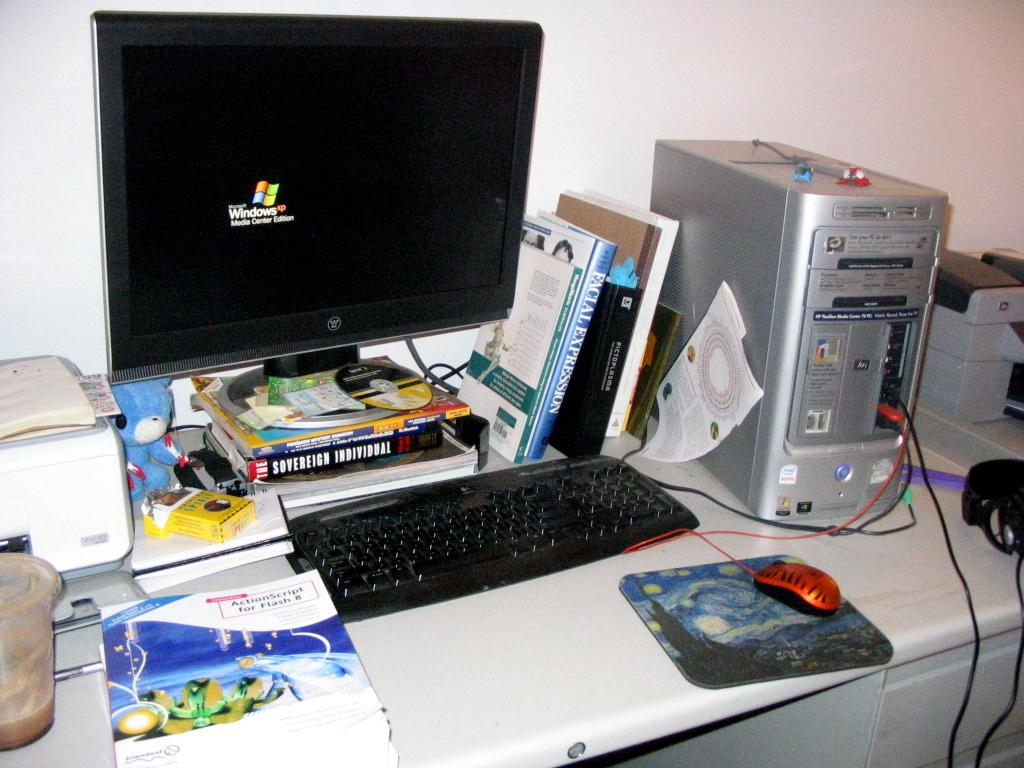<image>
Present a compact description of the photo's key features. The microsoft windows screen saver is displayed on the computer monitor. 